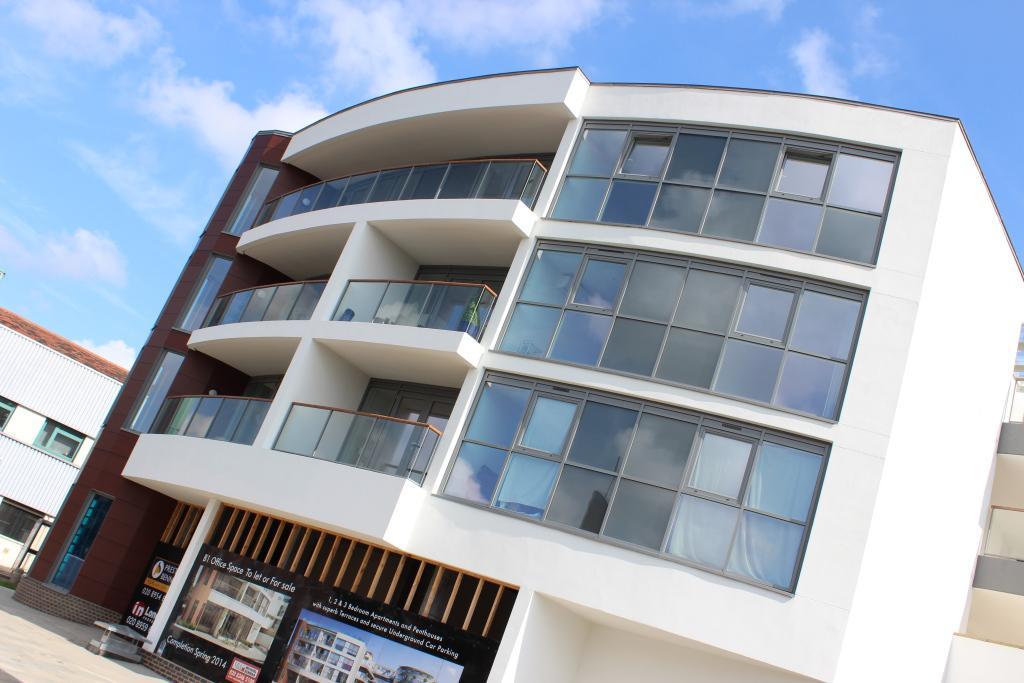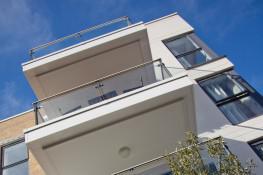The first image is the image on the left, the second image is the image on the right. For the images displayed, is the sentence "The left image is an upward view of a white-framed balcony with glass panels instead of rails in front of paned glass windows." factually correct? Answer yes or no. Yes. The first image is the image on the left, the second image is the image on the right. For the images displayed, is the sentence "The left image features the exterior of a building and the right image features the interior of a building." factually correct? Answer yes or no. No. 